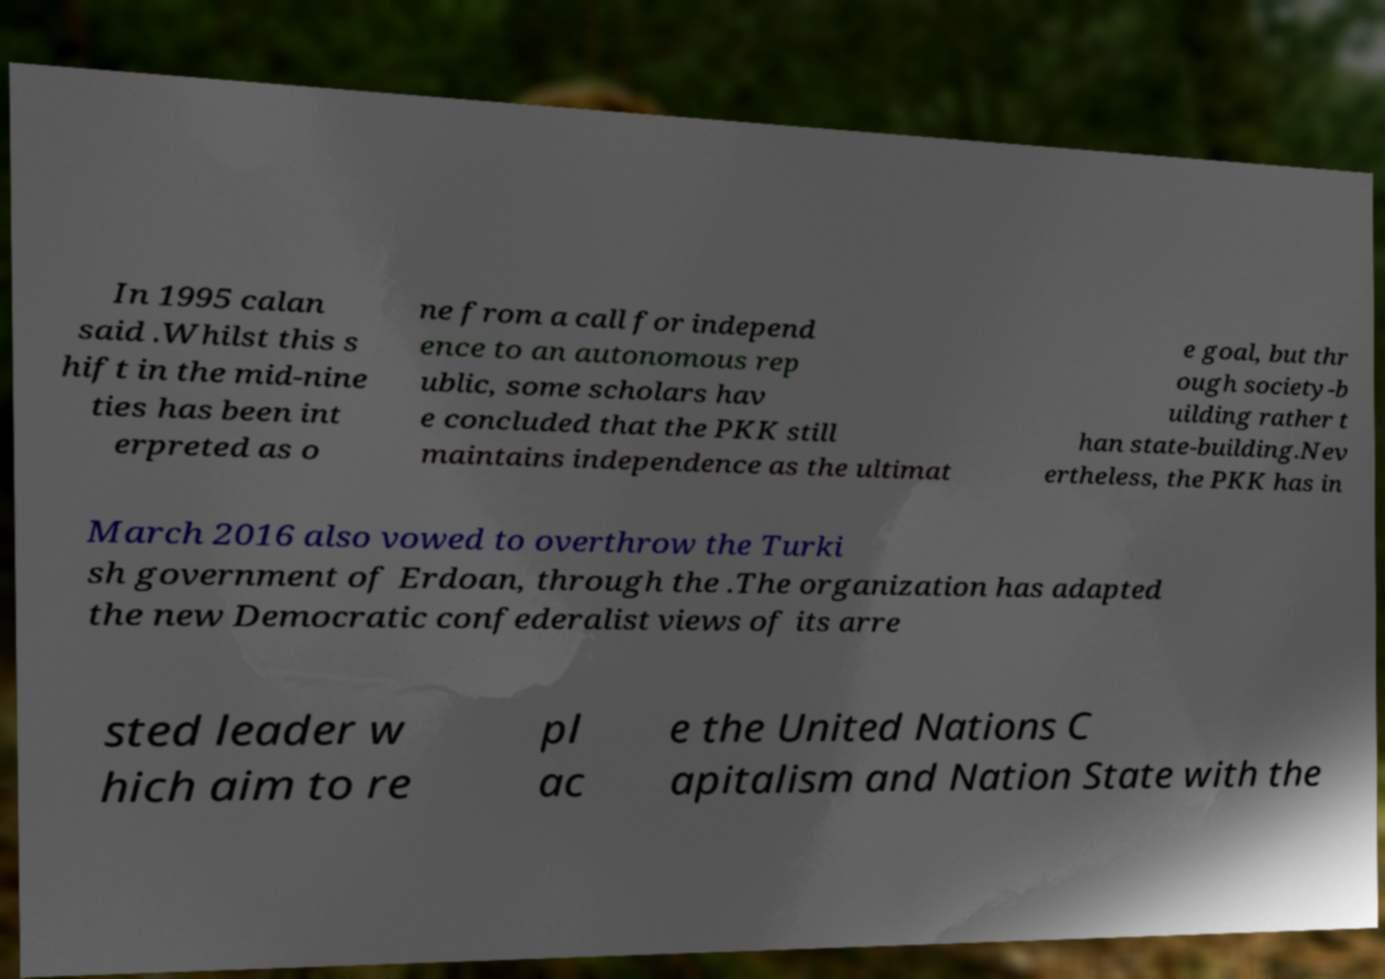What messages or text are displayed in this image? I need them in a readable, typed format. In 1995 calan said .Whilst this s hift in the mid-nine ties has been int erpreted as o ne from a call for independ ence to an autonomous rep ublic, some scholars hav e concluded that the PKK still maintains independence as the ultimat e goal, but thr ough society-b uilding rather t han state-building.Nev ertheless, the PKK has in March 2016 also vowed to overthrow the Turki sh government of Erdoan, through the .The organization has adapted the new Democratic confederalist views of its arre sted leader w hich aim to re pl ac e the United Nations C apitalism and Nation State with the 